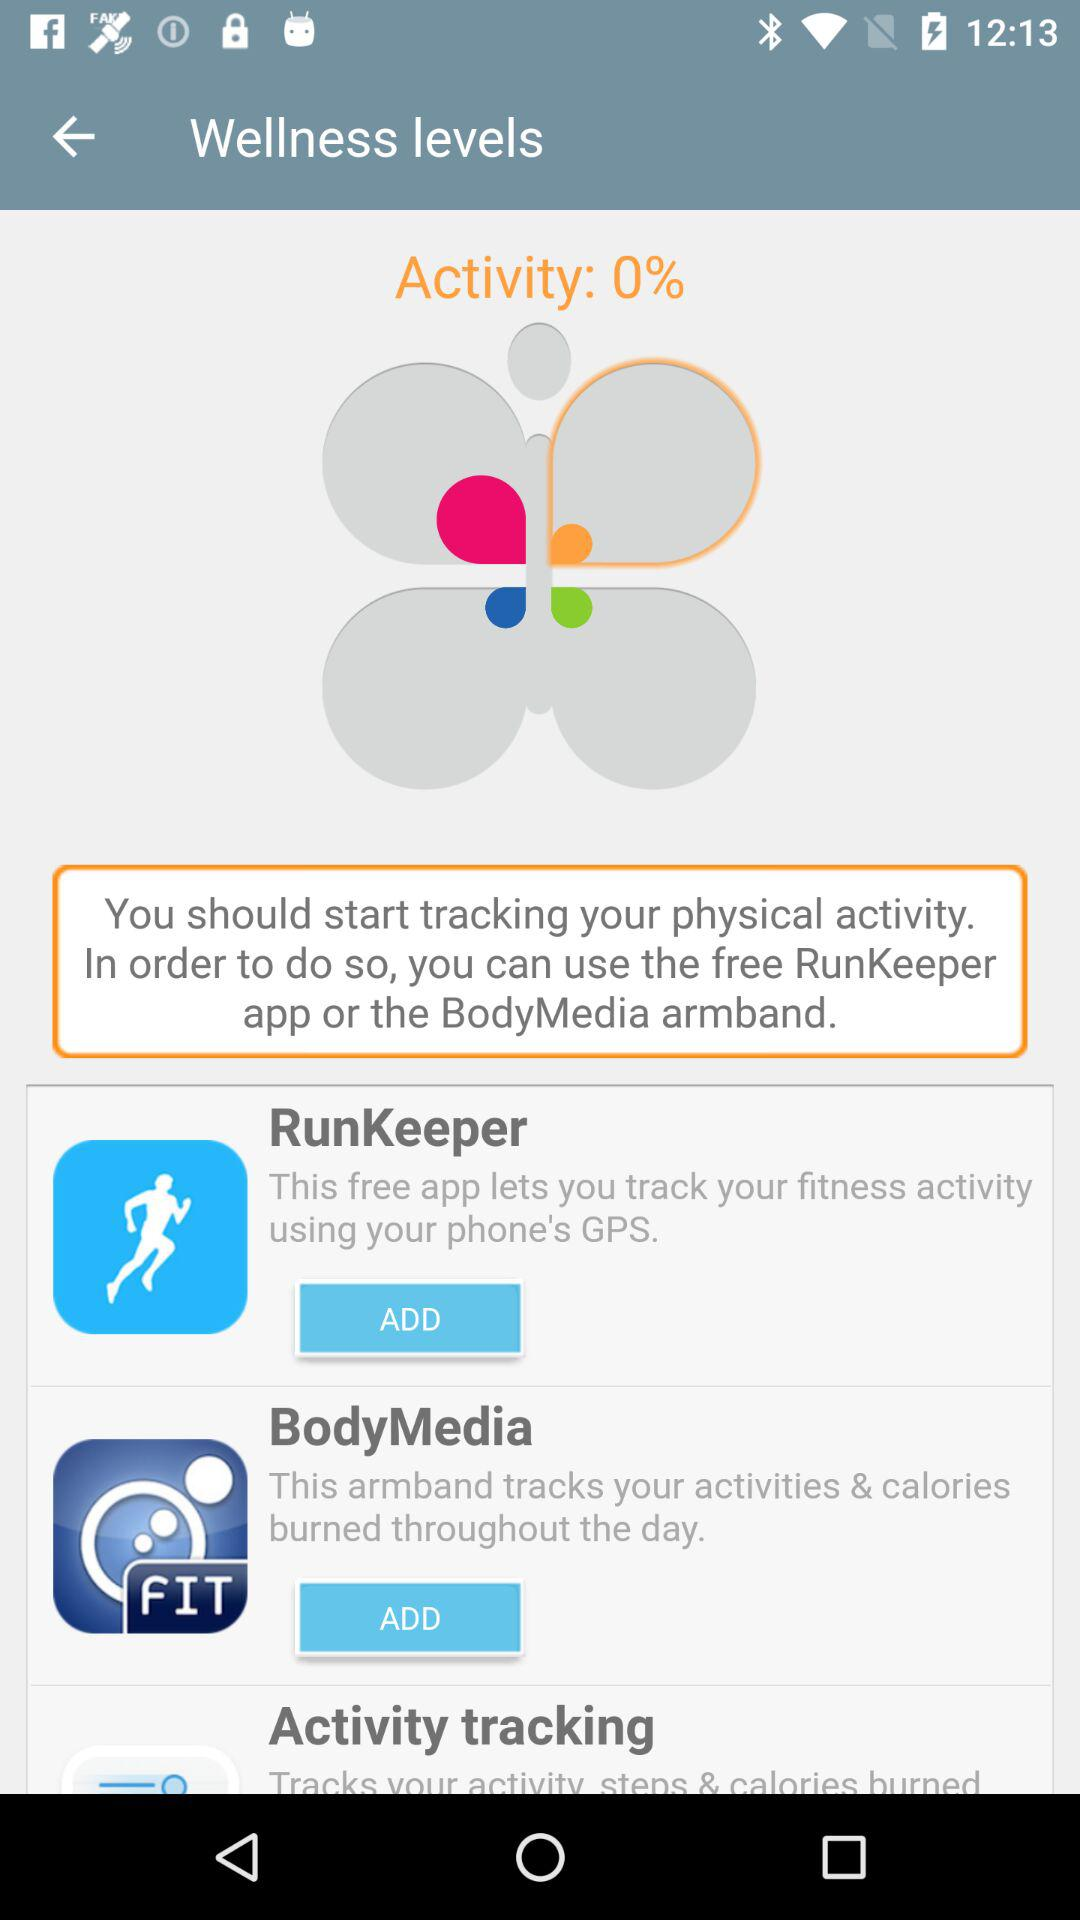How many apps can track physical activity?
Answer the question using a single word or phrase. 2 